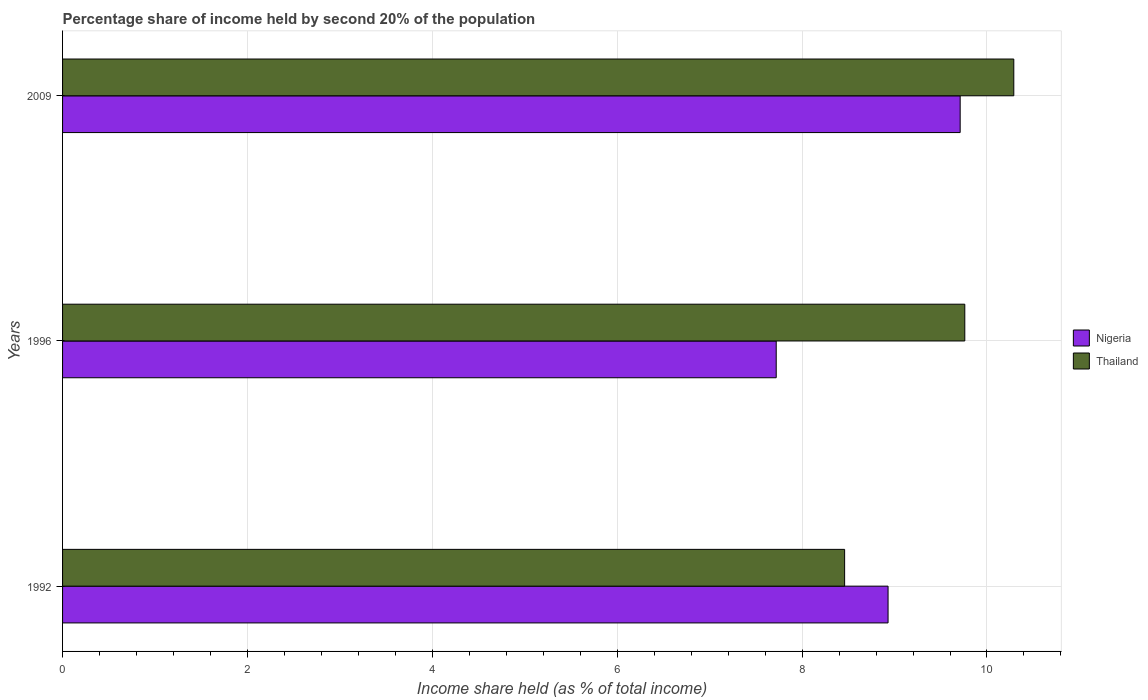How many different coloured bars are there?
Your response must be concise. 2. Are the number of bars per tick equal to the number of legend labels?
Your answer should be very brief. Yes. How many bars are there on the 1st tick from the top?
Offer a terse response. 2. What is the share of income held by second 20% of the population in Thailand in 1996?
Keep it short and to the point. 9.76. Across all years, what is the maximum share of income held by second 20% of the population in Nigeria?
Offer a terse response. 9.71. Across all years, what is the minimum share of income held by second 20% of the population in Thailand?
Your answer should be compact. 8.46. In which year was the share of income held by second 20% of the population in Thailand maximum?
Offer a terse response. 2009. In which year was the share of income held by second 20% of the population in Nigeria minimum?
Make the answer very short. 1996. What is the total share of income held by second 20% of the population in Thailand in the graph?
Offer a terse response. 28.51. What is the difference between the share of income held by second 20% of the population in Nigeria in 1996 and that in 2009?
Provide a succinct answer. -1.99. What is the difference between the share of income held by second 20% of the population in Nigeria in 1996 and the share of income held by second 20% of the population in Thailand in 2009?
Provide a succinct answer. -2.57. What is the average share of income held by second 20% of the population in Thailand per year?
Make the answer very short. 9.5. In the year 2009, what is the difference between the share of income held by second 20% of the population in Thailand and share of income held by second 20% of the population in Nigeria?
Provide a succinct answer. 0.58. What is the ratio of the share of income held by second 20% of the population in Nigeria in 1992 to that in 2009?
Provide a short and direct response. 0.92. Is the difference between the share of income held by second 20% of the population in Thailand in 1992 and 1996 greater than the difference between the share of income held by second 20% of the population in Nigeria in 1992 and 1996?
Your response must be concise. No. What is the difference between the highest and the second highest share of income held by second 20% of the population in Nigeria?
Your answer should be very brief. 0.78. What is the difference between the highest and the lowest share of income held by second 20% of the population in Nigeria?
Provide a succinct answer. 1.99. Is the sum of the share of income held by second 20% of the population in Nigeria in 1992 and 1996 greater than the maximum share of income held by second 20% of the population in Thailand across all years?
Provide a short and direct response. Yes. What does the 1st bar from the top in 2009 represents?
Keep it short and to the point. Thailand. What does the 2nd bar from the bottom in 1996 represents?
Offer a terse response. Thailand. How many years are there in the graph?
Your response must be concise. 3. Does the graph contain any zero values?
Offer a very short reply. No. Does the graph contain grids?
Give a very brief answer. Yes. How many legend labels are there?
Ensure brevity in your answer.  2. How are the legend labels stacked?
Offer a terse response. Vertical. What is the title of the graph?
Ensure brevity in your answer.  Percentage share of income held by second 20% of the population. Does "Luxembourg" appear as one of the legend labels in the graph?
Make the answer very short. No. What is the label or title of the X-axis?
Keep it short and to the point. Income share held (as % of total income). What is the Income share held (as % of total income) in Nigeria in 1992?
Your answer should be very brief. 8.93. What is the Income share held (as % of total income) in Thailand in 1992?
Your answer should be very brief. 8.46. What is the Income share held (as % of total income) of Nigeria in 1996?
Offer a terse response. 7.72. What is the Income share held (as % of total income) in Thailand in 1996?
Provide a short and direct response. 9.76. What is the Income share held (as % of total income) in Nigeria in 2009?
Ensure brevity in your answer.  9.71. What is the Income share held (as % of total income) in Thailand in 2009?
Ensure brevity in your answer.  10.29. Across all years, what is the maximum Income share held (as % of total income) of Nigeria?
Ensure brevity in your answer.  9.71. Across all years, what is the maximum Income share held (as % of total income) in Thailand?
Keep it short and to the point. 10.29. Across all years, what is the minimum Income share held (as % of total income) in Nigeria?
Your answer should be compact. 7.72. Across all years, what is the minimum Income share held (as % of total income) of Thailand?
Provide a short and direct response. 8.46. What is the total Income share held (as % of total income) of Nigeria in the graph?
Offer a terse response. 26.36. What is the total Income share held (as % of total income) of Thailand in the graph?
Ensure brevity in your answer.  28.51. What is the difference between the Income share held (as % of total income) in Nigeria in 1992 and that in 1996?
Ensure brevity in your answer.  1.21. What is the difference between the Income share held (as % of total income) in Thailand in 1992 and that in 1996?
Ensure brevity in your answer.  -1.3. What is the difference between the Income share held (as % of total income) in Nigeria in 1992 and that in 2009?
Offer a very short reply. -0.78. What is the difference between the Income share held (as % of total income) in Thailand in 1992 and that in 2009?
Ensure brevity in your answer.  -1.83. What is the difference between the Income share held (as % of total income) of Nigeria in 1996 and that in 2009?
Ensure brevity in your answer.  -1.99. What is the difference between the Income share held (as % of total income) of Thailand in 1996 and that in 2009?
Your response must be concise. -0.53. What is the difference between the Income share held (as % of total income) of Nigeria in 1992 and the Income share held (as % of total income) of Thailand in 1996?
Offer a terse response. -0.83. What is the difference between the Income share held (as % of total income) of Nigeria in 1992 and the Income share held (as % of total income) of Thailand in 2009?
Offer a very short reply. -1.36. What is the difference between the Income share held (as % of total income) of Nigeria in 1996 and the Income share held (as % of total income) of Thailand in 2009?
Give a very brief answer. -2.57. What is the average Income share held (as % of total income) in Nigeria per year?
Provide a short and direct response. 8.79. What is the average Income share held (as % of total income) in Thailand per year?
Keep it short and to the point. 9.5. In the year 1992, what is the difference between the Income share held (as % of total income) of Nigeria and Income share held (as % of total income) of Thailand?
Ensure brevity in your answer.  0.47. In the year 1996, what is the difference between the Income share held (as % of total income) of Nigeria and Income share held (as % of total income) of Thailand?
Offer a terse response. -2.04. In the year 2009, what is the difference between the Income share held (as % of total income) of Nigeria and Income share held (as % of total income) of Thailand?
Provide a succinct answer. -0.58. What is the ratio of the Income share held (as % of total income) in Nigeria in 1992 to that in 1996?
Ensure brevity in your answer.  1.16. What is the ratio of the Income share held (as % of total income) of Thailand in 1992 to that in 1996?
Give a very brief answer. 0.87. What is the ratio of the Income share held (as % of total income) of Nigeria in 1992 to that in 2009?
Provide a succinct answer. 0.92. What is the ratio of the Income share held (as % of total income) in Thailand in 1992 to that in 2009?
Offer a terse response. 0.82. What is the ratio of the Income share held (as % of total income) in Nigeria in 1996 to that in 2009?
Make the answer very short. 0.8. What is the ratio of the Income share held (as % of total income) of Thailand in 1996 to that in 2009?
Your response must be concise. 0.95. What is the difference between the highest and the second highest Income share held (as % of total income) of Nigeria?
Offer a terse response. 0.78. What is the difference between the highest and the second highest Income share held (as % of total income) of Thailand?
Keep it short and to the point. 0.53. What is the difference between the highest and the lowest Income share held (as % of total income) in Nigeria?
Your response must be concise. 1.99. What is the difference between the highest and the lowest Income share held (as % of total income) of Thailand?
Your answer should be very brief. 1.83. 